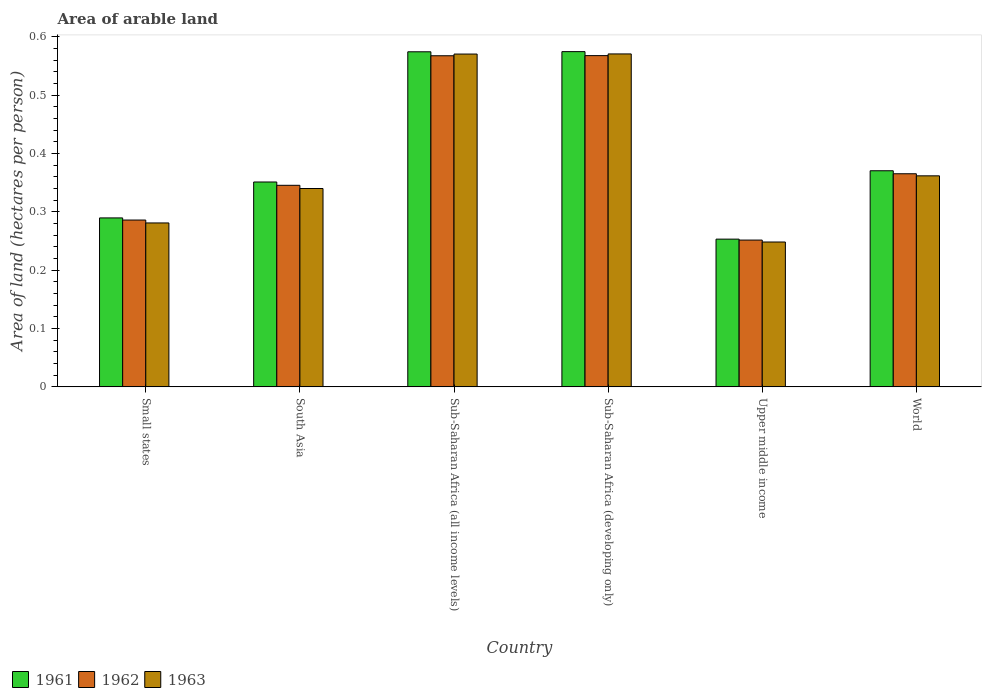How many different coloured bars are there?
Offer a terse response. 3. Are the number of bars per tick equal to the number of legend labels?
Make the answer very short. Yes. Are the number of bars on each tick of the X-axis equal?
Give a very brief answer. Yes. How many bars are there on the 1st tick from the left?
Your answer should be very brief. 3. How many bars are there on the 4th tick from the right?
Your answer should be compact. 3. What is the label of the 5th group of bars from the left?
Your answer should be compact. Upper middle income. In how many cases, is the number of bars for a given country not equal to the number of legend labels?
Give a very brief answer. 0. What is the total arable land in 1963 in Sub-Saharan Africa (all income levels)?
Your answer should be compact. 0.57. Across all countries, what is the maximum total arable land in 1963?
Offer a terse response. 0.57. Across all countries, what is the minimum total arable land in 1962?
Make the answer very short. 0.25. In which country was the total arable land in 1961 maximum?
Your response must be concise. Sub-Saharan Africa (developing only). In which country was the total arable land in 1962 minimum?
Make the answer very short. Upper middle income. What is the total total arable land in 1963 in the graph?
Your answer should be very brief. 2.37. What is the difference between the total arable land in 1963 in Sub-Saharan Africa (developing only) and that in World?
Offer a terse response. 0.21. What is the difference between the total arable land in 1962 in Small states and the total arable land in 1961 in South Asia?
Your answer should be very brief. -0.07. What is the average total arable land in 1963 per country?
Your answer should be compact. 0.4. What is the difference between the total arable land of/in 1963 and total arable land of/in 1961 in South Asia?
Provide a succinct answer. -0.01. In how many countries, is the total arable land in 1962 greater than 0.06 hectares per person?
Your answer should be very brief. 6. What is the ratio of the total arable land in 1962 in South Asia to that in Sub-Saharan Africa (developing only)?
Offer a terse response. 0.61. Is the total arable land in 1962 in Sub-Saharan Africa (all income levels) less than that in Sub-Saharan Africa (developing only)?
Your response must be concise. Yes. What is the difference between the highest and the second highest total arable land in 1963?
Provide a succinct answer. 0. What is the difference between the highest and the lowest total arable land in 1963?
Provide a succinct answer. 0.32. In how many countries, is the total arable land in 1963 greater than the average total arable land in 1963 taken over all countries?
Keep it short and to the point. 2. Is the sum of the total arable land in 1961 in Sub-Saharan Africa (all income levels) and Upper middle income greater than the maximum total arable land in 1962 across all countries?
Provide a succinct answer. Yes. How many countries are there in the graph?
Your response must be concise. 6. Does the graph contain grids?
Your answer should be very brief. No. What is the title of the graph?
Ensure brevity in your answer.  Area of arable land. What is the label or title of the X-axis?
Give a very brief answer. Country. What is the label or title of the Y-axis?
Provide a succinct answer. Area of land (hectares per person). What is the Area of land (hectares per person) of 1961 in Small states?
Offer a very short reply. 0.29. What is the Area of land (hectares per person) of 1962 in Small states?
Provide a succinct answer. 0.29. What is the Area of land (hectares per person) in 1963 in Small states?
Offer a very short reply. 0.28. What is the Area of land (hectares per person) in 1961 in South Asia?
Keep it short and to the point. 0.35. What is the Area of land (hectares per person) of 1962 in South Asia?
Your response must be concise. 0.35. What is the Area of land (hectares per person) in 1963 in South Asia?
Provide a short and direct response. 0.34. What is the Area of land (hectares per person) of 1961 in Sub-Saharan Africa (all income levels)?
Provide a short and direct response. 0.57. What is the Area of land (hectares per person) in 1962 in Sub-Saharan Africa (all income levels)?
Make the answer very short. 0.57. What is the Area of land (hectares per person) in 1963 in Sub-Saharan Africa (all income levels)?
Your response must be concise. 0.57. What is the Area of land (hectares per person) of 1961 in Sub-Saharan Africa (developing only)?
Keep it short and to the point. 0.57. What is the Area of land (hectares per person) of 1962 in Sub-Saharan Africa (developing only)?
Your answer should be very brief. 0.57. What is the Area of land (hectares per person) in 1963 in Sub-Saharan Africa (developing only)?
Your answer should be compact. 0.57. What is the Area of land (hectares per person) of 1961 in Upper middle income?
Your answer should be compact. 0.25. What is the Area of land (hectares per person) in 1962 in Upper middle income?
Provide a succinct answer. 0.25. What is the Area of land (hectares per person) in 1963 in Upper middle income?
Ensure brevity in your answer.  0.25. What is the Area of land (hectares per person) of 1961 in World?
Make the answer very short. 0.37. What is the Area of land (hectares per person) of 1962 in World?
Give a very brief answer. 0.37. What is the Area of land (hectares per person) of 1963 in World?
Your answer should be compact. 0.36. Across all countries, what is the maximum Area of land (hectares per person) of 1961?
Provide a succinct answer. 0.57. Across all countries, what is the maximum Area of land (hectares per person) of 1962?
Provide a short and direct response. 0.57. Across all countries, what is the maximum Area of land (hectares per person) in 1963?
Offer a terse response. 0.57. Across all countries, what is the minimum Area of land (hectares per person) in 1961?
Offer a very short reply. 0.25. Across all countries, what is the minimum Area of land (hectares per person) of 1962?
Provide a succinct answer. 0.25. Across all countries, what is the minimum Area of land (hectares per person) of 1963?
Your answer should be very brief. 0.25. What is the total Area of land (hectares per person) in 1961 in the graph?
Offer a very short reply. 2.41. What is the total Area of land (hectares per person) in 1962 in the graph?
Provide a succinct answer. 2.38. What is the total Area of land (hectares per person) in 1963 in the graph?
Ensure brevity in your answer.  2.37. What is the difference between the Area of land (hectares per person) in 1961 in Small states and that in South Asia?
Ensure brevity in your answer.  -0.06. What is the difference between the Area of land (hectares per person) in 1962 in Small states and that in South Asia?
Your answer should be compact. -0.06. What is the difference between the Area of land (hectares per person) in 1963 in Small states and that in South Asia?
Offer a very short reply. -0.06. What is the difference between the Area of land (hectares per person) in 1961 in Small states and that in Sub-Saharan Africa (all income levels)?
Keep it short and to the point. -0.28. What is the difference between the Area of land (hectares per person) in 1962 in Small states and that in Sub-Saharan Africa (all income levels)?
Your answer should be compact. -0.28. What is the difference between the Area of land (hectares per person) in 1963 in Small states and that in Sub-Saharan Africa (all income levels)?
Your answer should be very brief. -0.29. What is the difference between the Area of land (hectares per person) of 1961 in Small states and that in Sub-Saharan Africa (developing only)?
Your answer should be very brief. -0.28. What is the difference between the Area of land (hectares per person) of 1962 in Small states and that in Sub-Saharan Africa (developing only)?
Offer a very short reply. -0.28. What is the difference between the Area of land (hectares per person) of 1963 in Small states and that in Sub-Saharan Africa (developing only)?
Your response must be concise. -0.29. What is the difference between the Area of land (hectares per person) in 1961 in Small states and that in Upper middle income?
Keep it short and to the point. 0.04. What is the difference between the Area of land (hectares per person) in 1962 in Small states and that in Upper middle income?
Keep it short and to the point. 0.03. What is the difference between the Area of land (hectares per person) in 1963 in Small states and that in Upper middle income?
Offer a very short reply. 0.03. What is the difference between the Area of land (hectares per person) of 1961 in Small states and that in World?
Make the answer very short. -0.08. What is the difference between the Area of land (hectares per person) in 1962 in Small states and that in World?
Ensure brevity in your answer.  -0.08. What is the difference between the Area of land (hectares per person) in 1963 in Small states and that in World?
Provide a succinct answer. -0.08. What is the difference between the Area of land (hectares per person) of 1961 in South Asia and that in Sub-Saharan Africa (all income levels)?
Offer a very short reply. -0.22. What is the difference between the Area of land (hectares per person) in 1962 in South Asia and that in Sub-Saharan Africa (all income levels)?
Keep it short and to the point. -0.22. What is the difference between the Area of land (hectares per person) of 1963 in South Asia and that in Sub-Saharan Africa (all income levels)?
Your answer should be very brief. -0.23. What is the difference between the Area of land (hectares per person) in 1961 in South Asia and that in Sub-Saharan Africa (developing only)?
Your response must be concise. -0.22. What is the difference between the Area of land (hectares per person) in 1962 in South Asia and that in Sub-Saharan Africa (developing only)?
Provide a short and direct response. -0.22. What is the difference between the Area of land (hectares per person) of 1963 in South Asia and that in Sub-Saharan Africa (developing only)?
Your answer should be compact. -0.23. What is the difference between the Area of land (hectares per person) of 1961 in South Asia and that in Upper middle income?
Give a very brief answer. 0.1. What is the difference between the Area of land (hectares per person) of 1962 in South Asia and that in Upper middle income?
Provide a succinct answer. 0.09. What is the difference between the Area of land (hectares per person) of 1963 in South Asia and that in Upper middle income?
Give a very brief answer. 0.09. What is the difference between the Area of land (hectares per person) of 1961 in South Asia and that in World?
Your answer should be very brief. -0.02. What is the difference between the Area of land (hectares per person) in 1962 in South Asia and that in World?
Keep it short and to the point. -0.02. What is the difference between the Area of land (hectares per person) of 1963 in South Asia and that in World?
Keep it short and to the point. -0.02. What is the difference between the Area of land (hectares per person) in 1961 in Sub-Saharan Africa (all income levels) and that in Sub-Saharan Africa (developing only)?
Offer a very short reply. -0. What is the difference between the Area of land (hectares per person) of 1962 in Sub-Saharan Africa (all income levels) and that in Sub-Saharan Africa (developing only)?
Provide a succinct answer. -0. What is the difference between the Area of land (hectares per person) in 1963 in Sub-Saharan Africa (all income levels) and that in Sub-Saharan Africa (developing only)?
Offer a terse response. -0. What is the difference between the Area of land (hectares per person) of 1961 in Sub-Saharan Africa (all income levels) and that in Upper middle income?
Make the answer very short. 0.32. What is the difference between the Area of land (hectares per person) in 1962 in Sub-Saharan Africa (all income levels) and that in Upper middle income?
Give a very brief answer. 0.32. What is the difference between the Area of land (hectares per person) of 1963 in Sub-Saharan Africa (all income levels) and that in Upper middle income?
Provide a succinct answer. 0.32. What is the difference between the Area of land (hectares per person) of 1961 in Sub-Saharan Africa (all income levels) and that in World?
Offer a terse response. 0.2. What is the difference between the Area of land (hectares per person) of 1962 in Sub-Saharan Africa (all income levels) and that in World?
Provide a short and direct response. 0.2. What is the difference between the Area of land (hectares per person) in 1963 in Sub-Saharan Africa (all income levels) and that in World?
Provide a short and direct response. 0.21. What is the difference between the Area of land (hectares per person) in 1961 in Sub-Saharan Africa (developing only) and that in Upper middle income?
Your response must be concise. 0.32. What is the difference between the Area of land (hectares per person) of 1962 in Sub-Saharan Africa (developing only) and that in Upper middle income?
Keep it short and to the point. 0.32. What is the difference between the Area of land (hectares per person) of 1963 in Sub-Saharan Africa (developing only) and that in Upper middle income?
Provide a succinct answer. 0.32. What is the difference between the Area of land (hectares per person) in 1961 in Sub-Saharan Africa (developing only) and that in World?
Your response must be concise. 0.2. What is the difference between the Area of land (hectares per person) in 1962 in Sub-Saharan Africa (developing only) and that in World?
Ensure brevity in your answer.  0.2. What is the difference between the Area of land (hectares per person) of 1963 in Sub-Saharan Africa (developing only) and that in World?
Offer a very short reply. 0.21. What is the difference between the Area of land (hectares per person) in 1961 in Upper middle income and that in World?
Give a very brief answer. -0.12. What is the difference between the Area of land (hectares per person) of 1962 in Upper middle income and that in World?
Offer a terse response. -0.11. What is the difference between the Area of land (hectares per person) in 1963 in Upper middle income and that in World?
Your answer should be compact. -0.11. What is the difference between the Area of land (hectares per person) in 1961 in Small states and the Area of land (hectares per person) in 1962 in South Asia?
Your response must be concise. -0.06. What is the difference between the Area of land (hectares per person) of 1961 in Small states and the Area of land (hectares per person) of 1963 in South Asia?
Your answer should be compact. -0.05. What is the difference between the Area of land (hectares per person) of 1962 in Small states and the Area of land (hectares per person) of 1963 in South Asia?
Offer a terse response. -0.05. What is the difference between the Area of land (hectares per person) in 1961 in Small states and the Area of land (hectares per person) in 1962 in Sub-Saharan Africa (all income levels)?
Provide a short and direct response. -0.28. What is the difference between the Area of land (hectares per person) in 1961 in Small states and the Area of land (hectares per person) in 1963 in Sub-Saharan Africa (all income levels)?
Ensure brevity in your answer.  -0.28. What is the difference between the Area of land (hectares per person) of 1962 in Small states and the Area of land (hectares per person) of 1963 in Sub-Saharan Africa (all income levels)?
Give a very brief answer. -0.28. What is the difference between the Area of land (hectares per person) in 1961 in Small states and the Area of land (hectares per person) in 1962 in Sub-Saharan Africa (developing only)?
Your response must be concise. -0.28. What is the difference between the Area of land (hectares per person) of 1961 in Small states and the Area of land (hectares per person) of 1963 in Sub-Saharan Africa (developing only)?
Provide a succinct answer. -0.28. What is the difference between the Area of land (hectares per person) of 1962 in Small states and the Area of land (hectares per person) of 1963 in Sub-Saharan Africa (developing only)?
Ensure brevity in your answer.  -0.28. What is the difference between the Area of land (hectares per person) of 1961 in Small states and the Area of land (hectares per person) of 1962 in Upper middle income?
Your answer should be compact. 0.04. What is the difference between the Area of land (hectares per person) in 1961 in Small states and the Area of land (hectares per person) in 1963 in Upper middle income?
Provide a succinct answer. 0.04. What is the difference between the Area of land (hectares per person) in 1962 in Small states and the Area of land (hectares per person) in 1963 in Upper middle income?
Give a very brief answer. 0.04. What is the difference between the Area of land (hectares per person) of 1961 in Small states and the Area of land (hectares per person) of 1962 in World?
Your response must be concise. -0.08. What is the difference between the Area of land (hectares per person) of 1961 in Small states and the Area of land (hectares per person) of 1963 in World?
Offer a very short reply. -0.07. What is the difference between the Area of land (hectares per person) of 1962 in Small states and the Area of land (hectares per person) of 1963 in World?
Your response must be concise. -0.08. What is the difference between the Area of land (hectares per person) of 1961 in South Asia and the Area of land (hectares per person) of 1962 in Sub-Saharan Africa (all income levels)?
Your answer should be very brief. -0.22. What is the difference between the Area of land (hectares per person) of 1961 in South Asia and the Area of land (hectares per person) of 1963 in Sub-Saharan Africa (all income levels)?
Give a very brief answer. -0.22. What is the difference between the Area of land (hectares per person) of 1962 in South Asia and the Area of land (hectares per person) of 1963 in Sub-Saharan Africa (all income levels)?
Make the answer very short. -0.23. What is the difference between the Area of land (hectares per person) in 1961 in South Asia and the Area of land (hectares per person) in 1962 in Sub-Saharan Africa (developing only)?
Offer a very short reply. -0.22. What is the difference between the Area of land (hectares per person) in 1961 in South Asia and the Area of land (hectares per person) in 1963 in Sub-Saharan Africa (developing only)?
Keep it short and to the point. -0.22. What is the difference between the Area of land (hectares per person) in 1962 in South Asia and the Area of land (hectares per person) in 1963 in Sub-Saharan Africa (developing only)?
Provide a succinct answer. -0.23. What is the difference between the Area of land (hectares per person) in 1961 in South Asia and the Area of land (hectares per person) in 1962 in Upper middle income?
Your response must be concise. 0.1. What is the difference between the Area of land (hectares per person) of 1961 in South Asia and the Area of land (hectares per person) of 1963 in Upper middle income?
Provide a short and direct response. 0.1. What is the difference between the Area of land (hectares per person) of 1962 in South Asia and the Area of land (hectares per person) of 1963 in Upper middle income?
Provide a succinct answer. 0.1. What is the difference between the Area of land (hectares per person) in 1961 in South Asia and the Area of land (hectares per person) in 1962 in World?
Your answer should be very brief. -0.01. What is the difference between the Area of land (hectares per person) of 1961 in South Asia and the Area of land (hectares per person) of 1963 in World?
Your answer should be very brief. -0.01. What is the difference between the Area of land (hectares per person) in 1962 in South Asia and the Area of land (hectares per person) in 1963 in World?
Provide a short and direct response. -0.02. What is the difference between the Area of land (hectares per person) in 1961 in Sub-Saharan Africa (all income levels) and the Area of land (hectares per person) in 1962 in Sub-Saharan Africa (developing only)?
Give a very brief answer. 0.01. What is the difference between the Area of land (hectares per person) in 1961 in Sub-Saharan Africa (all income levels) and the Area of land (hectares per person) in 1963 in Sub-Saharan Africa (developing only)?
Provide a succinct answer. 0. What is the difference between the Area of land (hectares per person) in 1962 in Sub-Saharan Africa (all income levels) and the Area of land (hectares per person) in 1963 in Sub-Saharan Africa (developing only)?
Provide a succinct answer. -0. What is the difference between the Area of land (hectares per person) of 1961 in Sub-Saharan Africa (all income levels) and the Area of land (hectares per person) of 1962 in Upper middle income?
Make the answer very short. 0.32. What is the difference between the Area of land (hectares per person) in 1961 in Sub-Saharan Africa (all income levels) and the Area of land (hectares per person) in 1963 in Upper middle income?
Provide a short and direct response. 0.33. What is the difference between the Area of land (hectares per person) in 1962 in Sub-Saharan Africa (all income levels) and the Area of land (hectares per person) in 1963 in Upper middle income?
Your answer should be very brief. 0.32. What is the difference between the Area of land (hectares per person) in 1961 in Sub-Saharan Africa (all income levels) and the Area of land (hectares per person) in 1962 in World?
Keep it short and to the point. 0.21. What is the difference between the Area of land (hectares per person) of 1961 in Sub-Saharan Africa (all income levels) and the Area of land (hectares per person) of 1963 in World?
Provide a succinct answer. 0.21. What is the difference between the Area of land (hectares per person) of 1962 in Sub-Saharan Africa (all income levels) and the Area of land (hectares per person) of 1963 in World?
Provide a succinct answer. 0.21. What is the difference between the Area of land (hectares per person) in 1961 in Sub-Saharan Africa (developing only) and the Area of land (hectares per person) in 1962 in Upper middle income?
Your response must be concise. 0.32. What is the difference between the Area of land (hectares per person) of 1961 in Sub-Saharan Africa (developing only) and the Area of land (hectares per person) of 1963 in Upper middle income?
Offer a very short reply. 0.33. What is the difference between the Area of land (hectares per person) of 1962 in Sub-Saharan Africa (developing only) and the Area of land (hectares per person) of 1963 in Upper middle income?
Ensure brevity in your answer.  0.32. What is the difference between the Area of land (hectares per person) in 1961 in Sub-Saharan Africa (developing only) and the Area of land (hectares per person) in 1962 in World?
Your answer should be compact. 0.21. What is the difference between the Area of land (hectares per person) of 1961 in Sub-Saharan Africa (developing only) and the Area of land (hectares per person) of 1963 in World?
Provide a short and direct response. 0.21. What is the difference between the Area of land (hectares per person) of 1962 in Sub-Saharan Africa (developing only) and the Area of land (hectares per person) of 1963 in World?
Keep it short and to the point. 0.21. What is the difference between the Area of land (hectares per person) in 1961 in Upper middle income and the Area of land (hectares per person) in 1962 in World?
Your answer should be compact. -0.11. What is the difference between the Area of land (hectares per person) of 1961 in Upper middle income and the Area of land (hectares per person) of 1963 in World?
Give a very brief answer. -0.11. What is the difference between the Area of land (hectares per person) in 1962 in Upper middle income and the Area of land (hectares per person) in 1963 in World?
Provide a short and direct response. -0.11. What is the average Area of land (hectares per person) in 1961 per country?
Offer a terse response. 0.4. What is the average Area of land (hectares per person) in 1962 per country?
Your answer should be compact. 0.4. What is the average Area of land (hectares per person) of 1963 per country?
Your answer should be compact. 0.4. What is the difference between the Area of land (hectares per person) in 1961 and Area of land (hectares per person) in 1962 in Small states?
Offer a very short reply. 0. What is the difference between the Area of land (hectares per person) in 1961 and Area of land (hectares per person) in 1963 in Small states?
Offer a terse response. 0.01. What is the difference between the Area of land (hectares per person) of 1962 and Area of land (hectares per person) of 1963 in Small states?
Your answer should be compact. 0.01. What is the difference between the Area of land (hectares per person) of 1961 and Area of land (hectares per person) of 1962 in South Asia?
Your answer should be very brief. 0.01. What is the difference between the Area of land (hectares per person) of 1961 and Area of land (hectares per person) of 1963 in South Asia?
Provide a succinct answer. 0.01. What is the difference between the Area of land (hectares per person) in 1962 and Area of land (hectares per person) in 1963 in South Asia?
Your answer should be compact. 0.01. What is the difference between the Area of land (hectares per person) in 1961 and Area of land (hectares per person) in 1962 in Sub-Saharan Africa (all income levels)?
Your response must be concise. 0.01. What is the difference between the Area of land (hectares per person) in 1961 and Area of land (hectares per person) in 1963 in Sub-Saharan Africa (all income levels)?
Give a very brief answer. 0. What is the difference between the Area of land (hectares per person) in 1962 and Area of land (hectares per person) in 1963 in Sub-Saharan Africa (all income levels)?
Make the answer very short. -0. What is the difference between the Area of land (hectares per person) of 1961 and Area of land (hectares per person) of 1962 in Sub-Saharan Africa (developing only)?
Offer a very short reply. 0.01. What is the difference between the Area of land (hectares per person) of 1961 and Area of land (hectares per person) of 1963 in Sub-Saharan Africa (developing only)?
Offer a very short reply. 0. What is the difference between the Area of land (hectares per person) in 1962 and Area of land (hectares per person) in 1963 in Sub-Saharan Africa (developing only)?
Provide a succinct answer. -0. What is the difference between the Area of land (hectares per person) in 1961 and Area of land (hectares per person) in 1962 in Upper middle income?
Make the answer very short. 0. What is the difference between the Area of land (hectares per person) in 1961 and Area of land (hectares per person) in 1963 in Upper middle income?
Offer a very short reply. 0. What is the difference between the Area of land (hectares per person) in 1962 and Area of land (hectares per person) in 1963 in Upper middle income?
Offer a terse response. 0. What is the difference between the Area of land (hectares per person) in 1961 and Area of land (hectares per person) in 1962 in World?
Offer a very short reply. 0.01. What is the difference between the Area of land (hectares per person) of 1961 and Area of land (hectares per person) of 1963 in World?
Ensure brevity in your answer.  0.01. What is the difference between the Area of land (hectares per person) in 1962 and Area of land (hectares per person) in 1963 in World?
Ensure brevity in your answer.  0. What is the ratio of the Area of land (hectares per person) in 1961 in Small states to that in South Asia?
Provide a succinct answer. 0.82. What is the ratio of the Area of land (hectares per person) of 1962 in Small states to that in South Asia?
Offer a terse response. 0.83. What is the ratio of the Area of land (hectares per person) of 1963 in Small states to that in South Asia?
Ensure brevity in your answer.  0.83. What is the ratio of the Area of land (hectares per person) of 1961 in Small states to that in Sub-Saharan Africa (all income levels)?
Your answer should be compact. 0.5. What is the ratio of the Area of land (hectares per person) of 1962 in Small states to that in Sub-Saharan Africa (all income levels)?
Ensure brevity in your answer.  0.5. What is the ratio of the Area of land (hectares per person) in 1963 in Small states to that in Sub-Saharan Africa (all income levels)?
Your response must be concise. 0.49. What is the ratio of the Area of land (hectares per person) in 1961 in Small states to that in Sub-Saharan Africa (developing only)?
Ensure brevity in your answer.  0.5. What is the ratio of the Area of land (hectares per person) of 1962 in Small states to that in Sub-Saharan Africa (developing only)?
Ensure brevity in your answer.  0.5. What is the ratio of the Area of land (hectares per person) in 1963 in Small states to that in Sub-Saharan Africa (developing only)?
Make the answer very short. 0.49. What is the ratio of the Area of land (hectares per person) in 1961 in Small states to that in Upper middle income?
Provide a short and direct response. 1.14. What is the ratio of the Area of land (hectares per person) of 1962 in Small states to that in Upper middle income?
Your answer should be very brief. 1.14. What is the ratio of the Area of land (hectares per person) in 1963 in Small states to that in Upper middle income?
Your answer should be very brief. 1.13. What is the ratio of the Area of land (hectares per person) of 1961 in Small states to that in World?
Make the answer very short. 0.78. What is the ratio of the Area of land (hectares per person) of 1962 in Small states to that in World?
Your answer should be compact. 0.78. What is the ratio of the Area of land (hectares per person) in 1963 in Small states to that in World?
Your answer should be compact. 0.78. What is the ratio of the Area of land (hectares per person) in 1961 in South Asia to that in Sub-Saharan Africa (all income levels)?
Offer a terse response. 0.61. What is the ratio of the Area of land (hectares per person) of 1962 in South Asia to that in Sub-Saharan Africa (all income levels)?
Keep it short and to the point. 0.61. What is the ratio of the Area of land (hectares per person) of 1963 in South Asia to that in Sub-Saharan Africa (all income levels)?
Offer a terse response. 0.6. What is the ratio of the Area of land (hectares per person) of 1961 in South Asia to that in Sub-Saharan Africa (developing only)?
Offer a terse response. 0.61. What is the ratio of the Area of land (hectares per person) of 1962 in South Asia to that in Sub-Saharan Africa (developing only)?
Your answer should be very brief. 0.61. What is the ratio of the Area of land (hectares per person) of 1963 in South Asia to that in Sub-Saharan Africa (developing only)?
Your answer should be very brief. 0.6. What is the ratio of the Area of land (hectares per person) of 1961 in South Asia to that in Upper middle income?
Provide a succinct answer. 1.39. What is the ratio of the Area of land (hectares per person) of 1962 in South Asia to that in Upper middle income?
Provide a succinct answer. 1.37. What is the ratio of the Area of land (hectares per person) in 1963 in South Asia to that in Upper middle income?
Your answer should be very brief. 1.37. What is the ratio of the Area of land (hectares per person) of 1961 in South Asia to that in World?
Your response must be concise. 0.95. What is the ratio of the Area of land (hectares per person) in 1962 in South Asia to that in World?
Your answer should be compact. 0.95. What is the ratio of the Area of land (hectares per person) of 1963 in South Asia to that in World?
Keep it short and to the point. 0.94. What is the ratio of the Area of land (hectares per person) in 1961 in Sub-Saharan Africa (all income levels) to that in Sub-Saharan Africa (developing only)?
Make the answer very short. 1. What is the ratio of the Area of land (hectares per person) in 1963 in Sub-Saharan Africa (all income levels) to that in Sub-Saharan Africa (developing only)?
Your answer should be very brief. 1. What is the ratio of the Area of land (hectares per person) in 1961 in Sub-Saharan Africa (all income levels) to that in Upper middle income?
Ensure brevity in your answer.  2.27. What is the ratio of the Area of land (hectares per person) in 1962 in Sub-Saharan Africa (all income levels) to that in Upper middle income?
Provide a short and direct response. 2.26. What is the ratio of the Area of land (hectares per person) in 1963 in Sub-Saharan Africa (all income levels) to that in Upper middle income?
Offer a terse response. 2.3. What is the ratio of the Area of land (hectares per person) of 1961 in Sub-Saharan Africa (all income levels) to that in World?
Your answer should be compact. 1.55. What is the ratio of the Area of land (hectares per person) in 1962 in Sub-Saharan Africa (all income levels) to that in World?
Offer a very short reply. 1.55. What is the ratio of the Area of land (hectares per person) of 1963 in Sub-Saharan Africa (all income levels) to that in World?
Provide a succinct answer. 1.58. What is the ratio of the Area of land (hectares per person) of 1961 in Sub-Saharan Africa (developing only) to that in Upper middle income?
Offer a terse response. 2.27. What is the ratio of the Area of land (hectares per person) in 1962 in Sub-Saharan Africa (developing only) to that in Upper middle income?
Ensure brevity in your answer.  2.26. What is the ratio of the Area of land (hectares per person) of 1963 in Sub-Saharan Africa (developing only) to that in Upper middle income?
Offer a terse response. 2.3. What is the ratio of the Area of land (hectares per person) of 1961 in Sub-Saharan Africa (developing only) to that in World?
Provide a succinct answer. 1.55. What is the ratio of the Area of land (hectares per person) in 1962 in Sub-Saharan Africa (developing only) to that in World?
Your response must be concise. 1.55. What is the ratio of the Area of land (hectares per person) of 1963 in Sub-Saharan Africa (developing only) to that in World?
Offer a very short reply. 1.58. What is the ratio of the Area of land (hectares per person) of 1961 in Upper middle income to that in World?
Provide a short and direct response. 0.68. What is the ratio of the Area of land (hectares per person) in 1962 in Upper middle income to that in World?
Provide a short and direct response. 0.69. What is the ratio of the Area of land (hectares per person) of 1963 in Upper middle income to that in World?
Offer a terse response. 0.69. What is the difference between the highest and the second highest Area of land (hectares per person) of 1961?
Provide a succinct answer. 0. What is the difference between the highest and the second highest Area of land (hectares per person) of 1963?
Provide a short and direct response. 0. What is the difference between the highest and the lowest Area of land (hectares per person) of 1961?
Give a very brief answer. 0.32. What is the difference between the highest and the lowest Area of land (hectares per person) in 1962?
Offer a terse response. 0.32. What is the difference between the highest and the lowest Area of land (hectares per person) in 1963?
Provide a succinct answer. 0.32. 